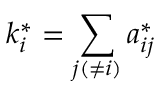<formula> <loc_0><loc_0><loc_500><loc_500>k _ { i } ^ { * } = \sum _ { j ( \neq i ) } a _ { i j } ^ { * }</formula> 